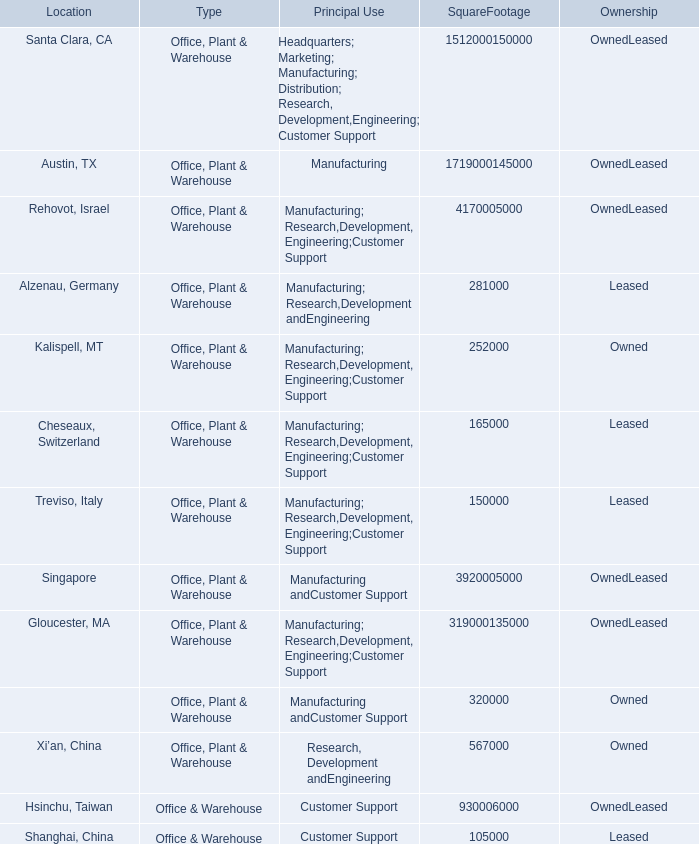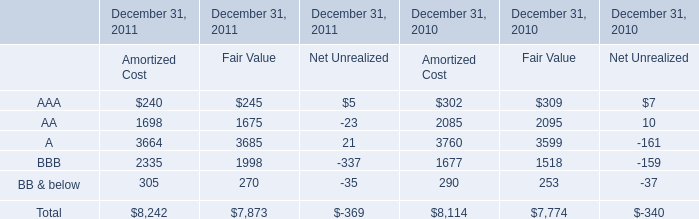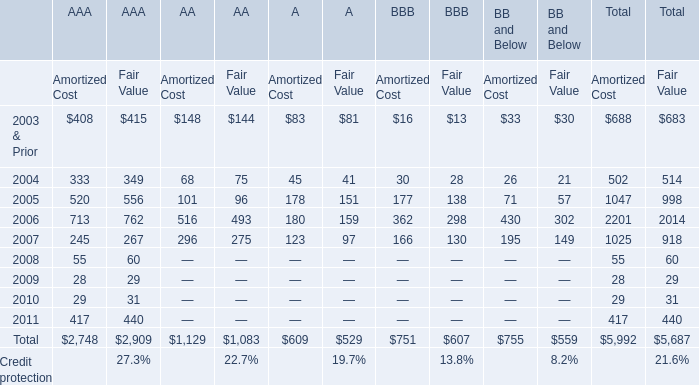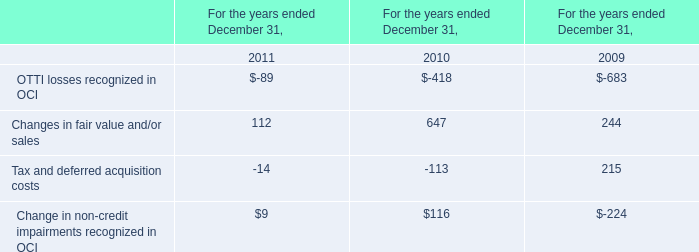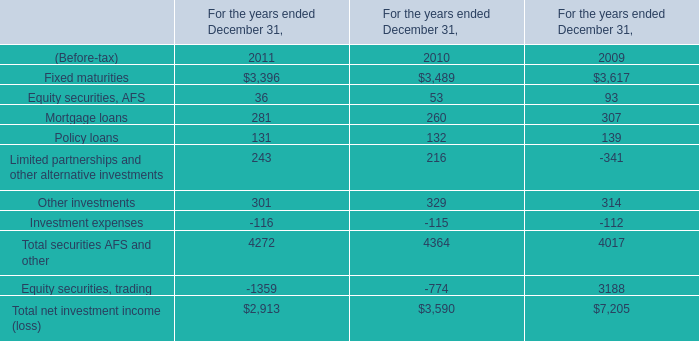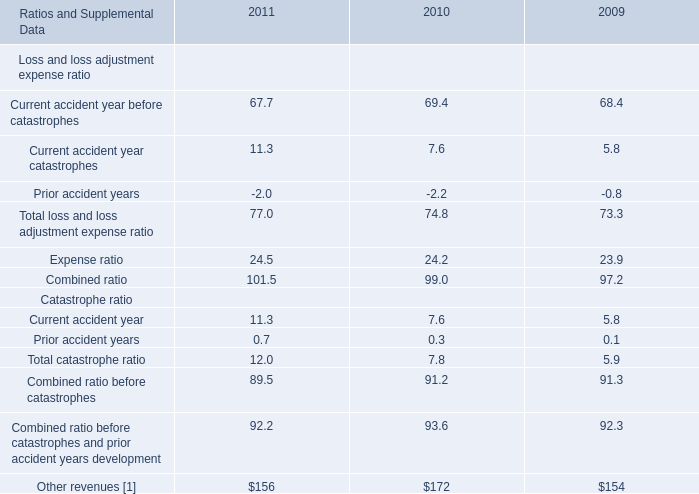What was the average value of the A in the years where AAA is positive? 
Computations: ((((3664 + 3685) + 3760) + 3599) / 2)
Answer: 7354.0. 